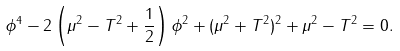<formula> <loc_0><loc_0><loc_500><loc_500>\phi ^ { 4 } - 2 \left ( \mu ^ { 2 } - T ^ { 2 } + \frac { 1 } { 2 } \right ) \phi ^ { 2 } + ( \mu ^ { 2 } + T ^ { 2 } ) ^ { 2 } + \mu ^ { 2 } - T ^ { 2 } = 0 .</formula> 